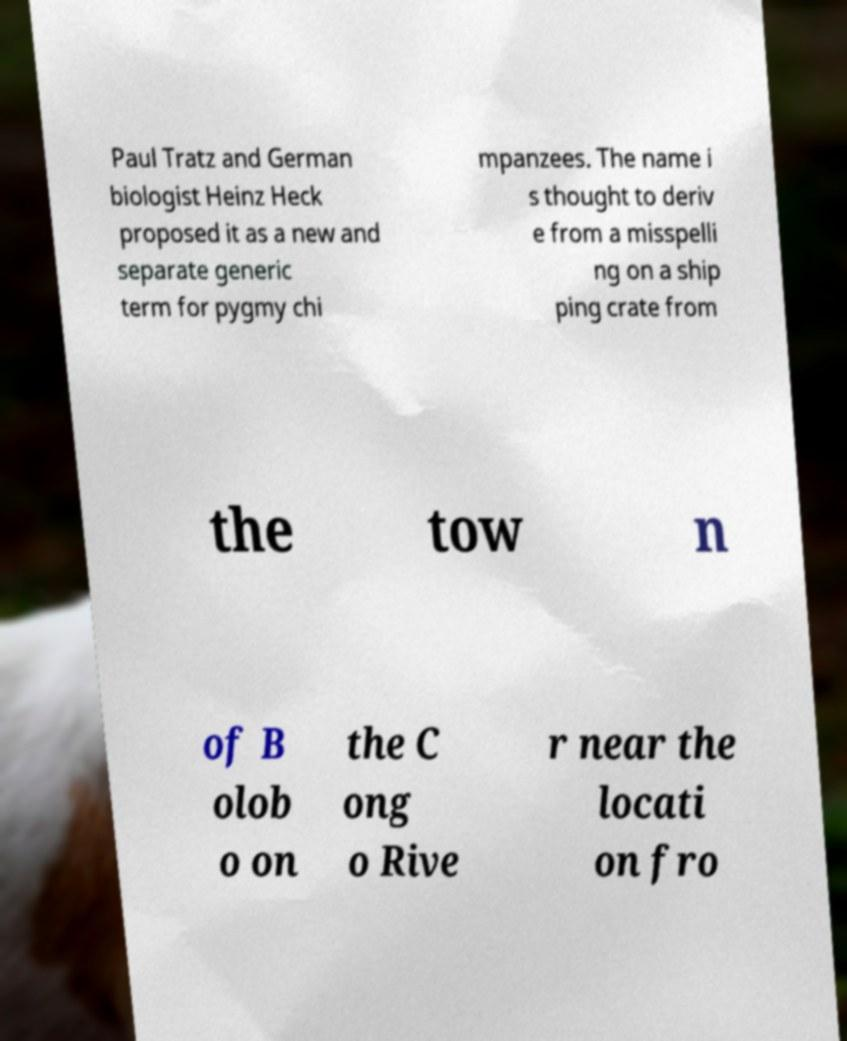I need the written content from this picture converted into text. Can you do that? Paul Tratz and German biologist Heinz Heck proposed it as a new and separate generic term for pygmy chi mpanzees. The name i s thought to deriv e from a misspelli ng on a ship ping crate from the tow n of B olob o on the C ong o Rive r near the locati on fro 